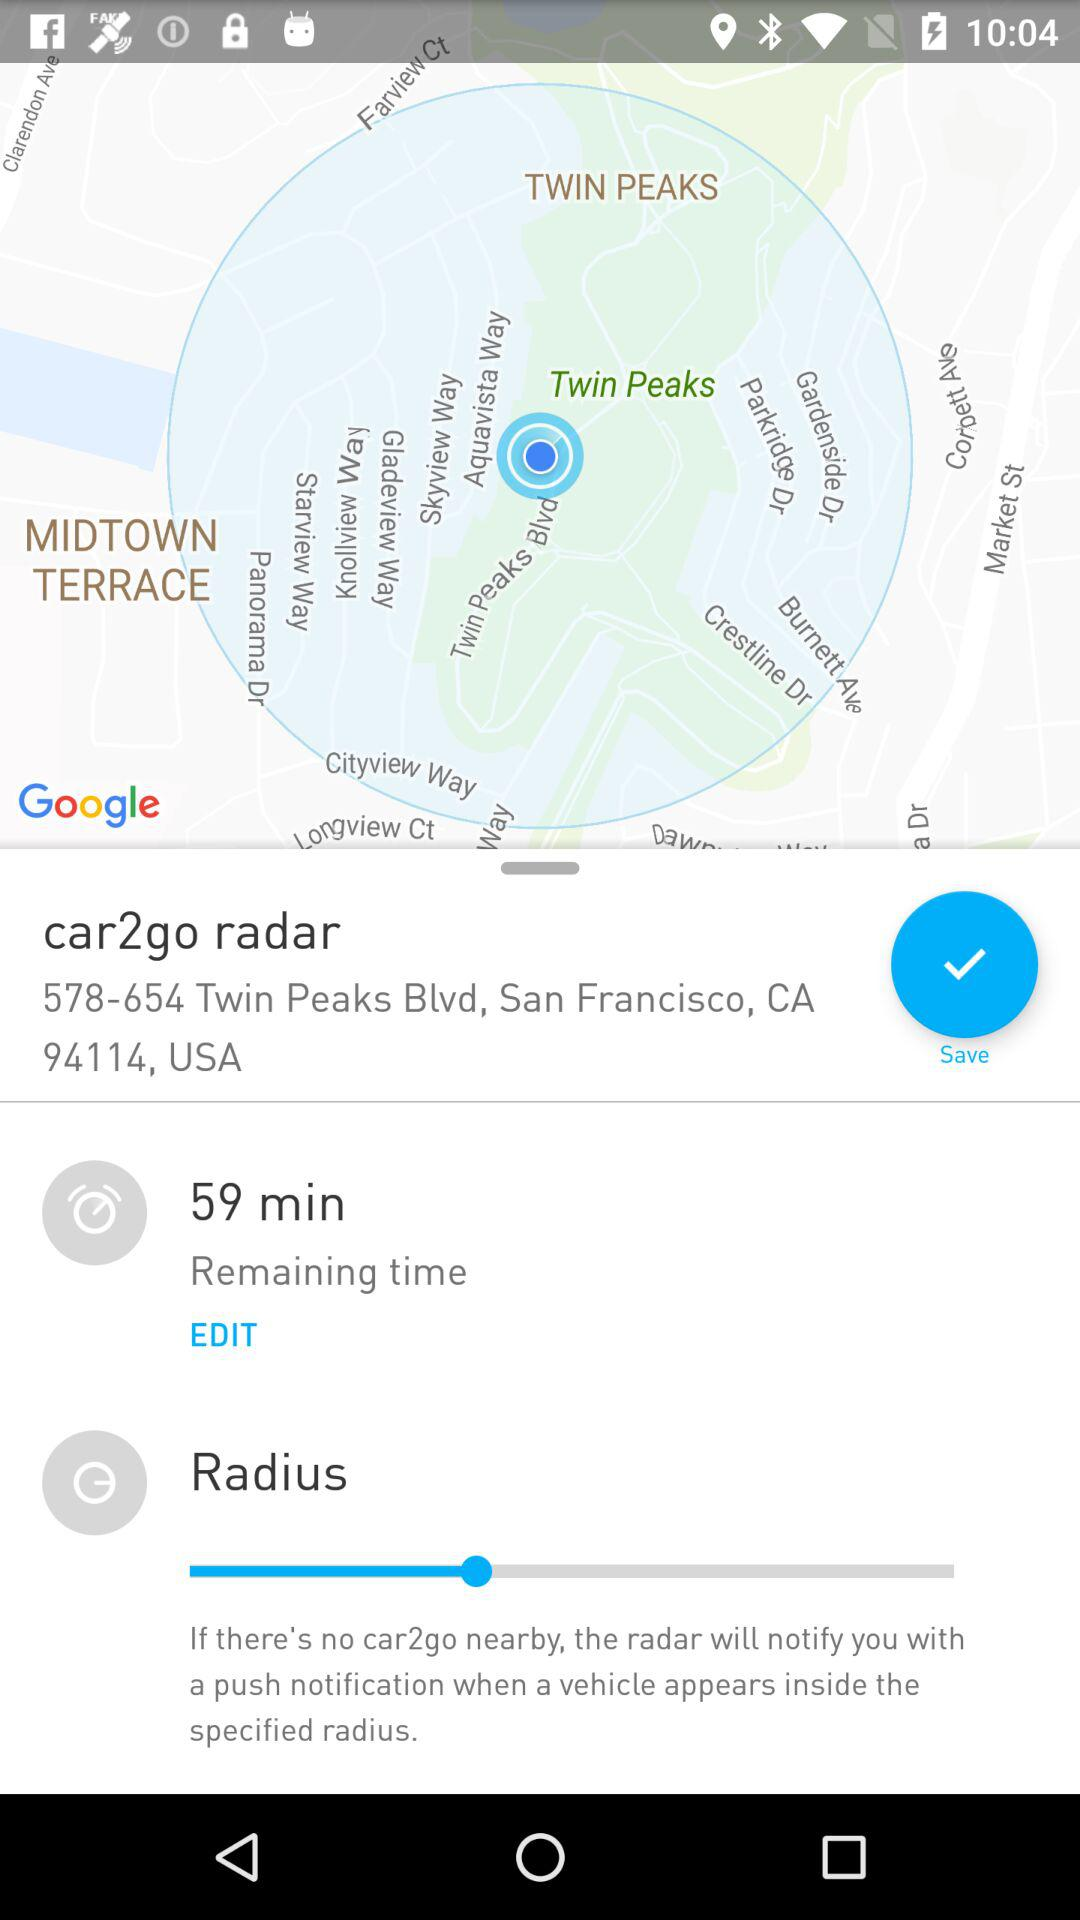What is the location? The location is 578-654 Twin Peaks Blvd, San Francisco, CA 94114, USA. 